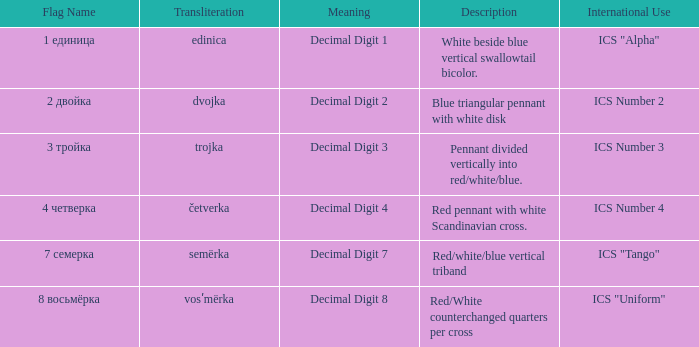What is the name of the flag that means decimal digit 2? 2 двойка. 